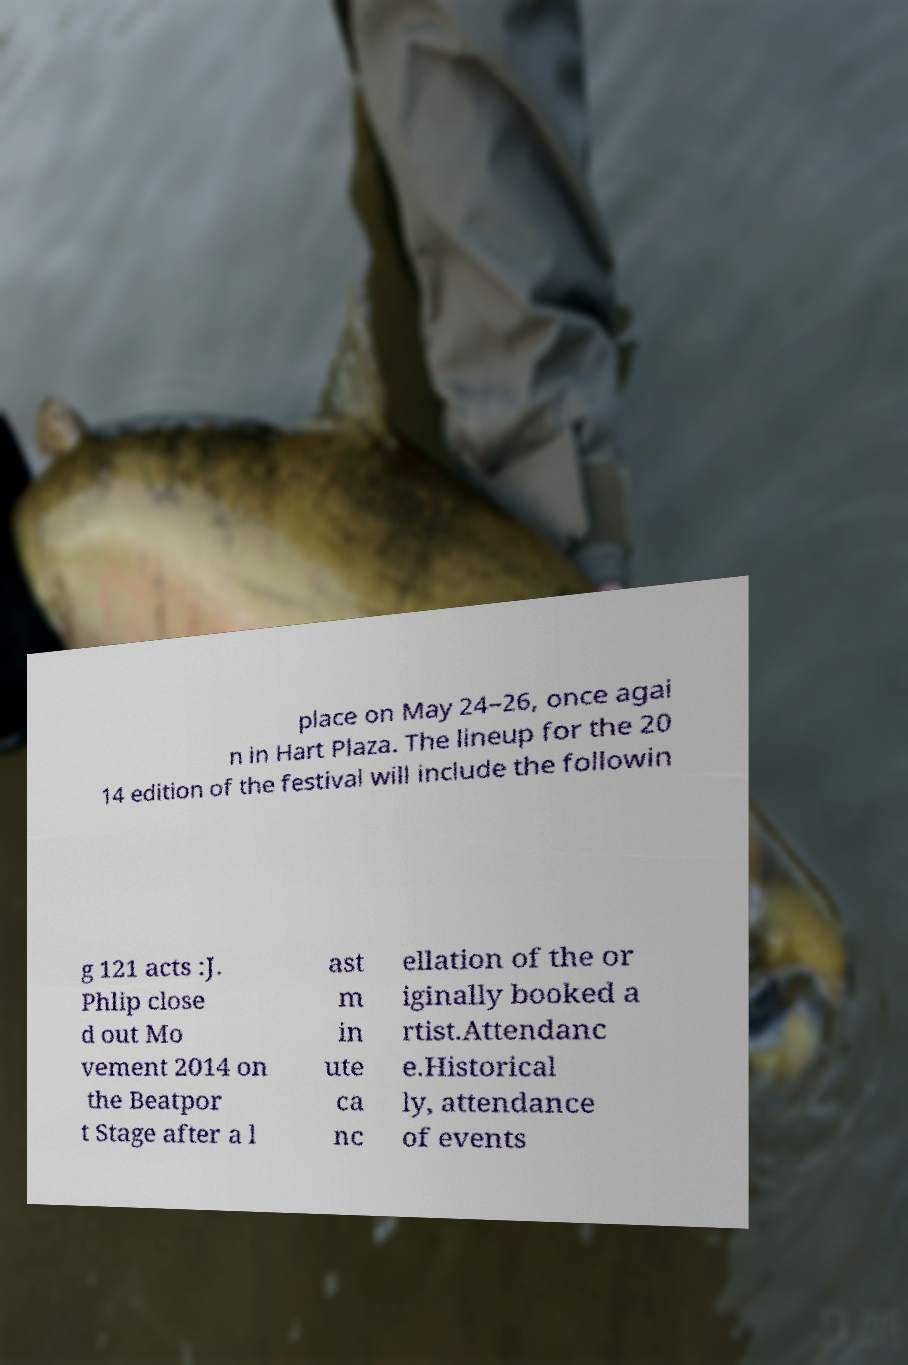Can you read and provide the text displayed in the image?This photo seems to have some interesting text. Can you extract and type it out for me? place on May 24–26, once agai n in Hart Plaza. The lineup for the 20 14 edition of the festival will include the followin g 121 acts :J. Phlip close d out Mo vement 2014 on the Beatpor t Stage after a l ast m in ute ca nc ellation of the or iginally booked a rtist.Attendanc e.Historical ly, attendance of events 